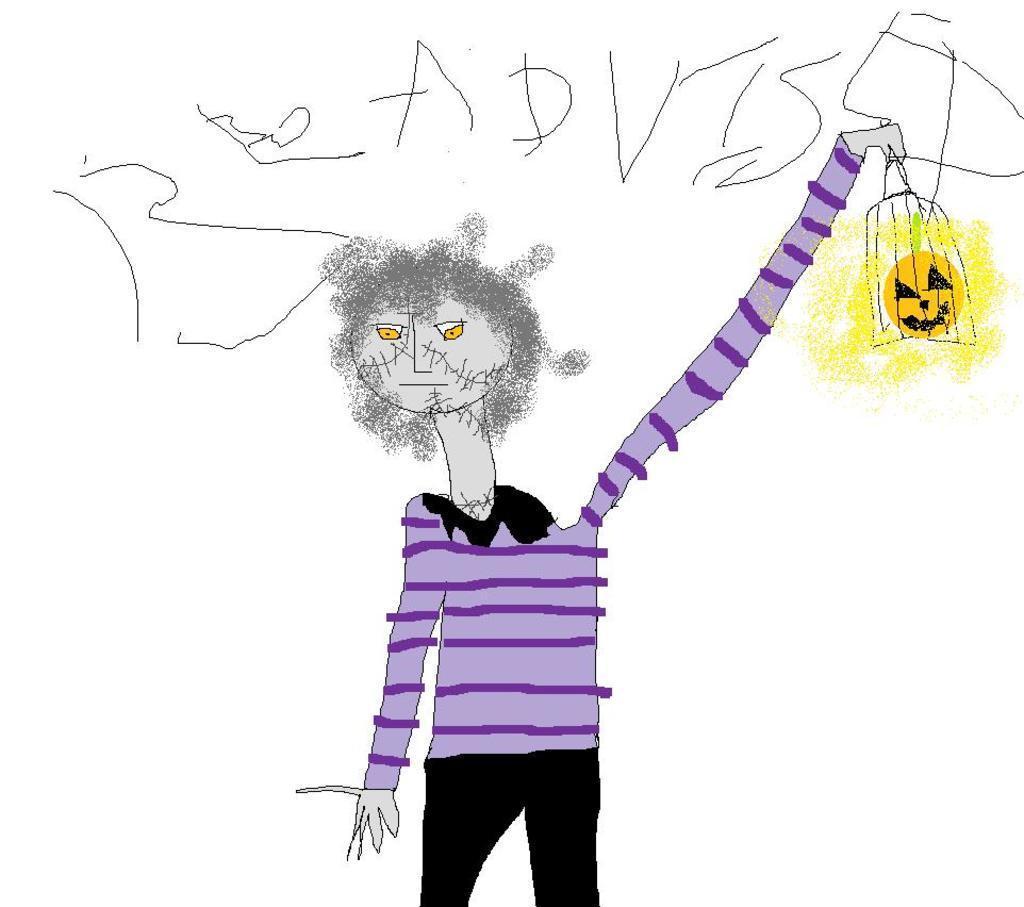In one or two sentences, can you explain what this image depicts? In this image there is a drawing of a person as we can see in the bottom of this image and there is some text written on the top of this image. 